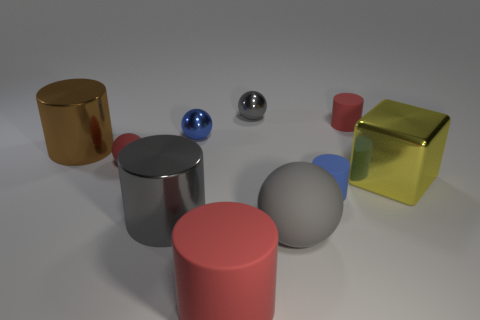How many cylinders are large gray objects or blue things?
Your answer should be compact. 2. How many things are both behind the large yellow metallic block and in front of the small blue metallic object?
Your response must be concise. 2. There is a rubber ball right of the tiny blue metal thing; what is its color?
Offer a terse response. Gray. The yellow block that is made of the same material as the brown cylinder is what size?
Give a very brief answer. Large. What number of brown metallic objects are to the left of the tiny cylinder in front of the large yellow metallic block?
Give a very brief answer. 1. There is a large ball; how many red things are behind it?
Your answer should be very brief. 2. There is a tiny metal sphere behind the red matte cylinder behind the big shiny cylinder behind the metallic block; what color is it?
Offer a very short reply. Gray. There is a matte cylinder on the left side of the gray matte object; is its color the same as the tiny cylinder that is behind the big yellow metal object?
Your response must be concise. Yes. What shape is the gray metal thing that is on the right side of the red thing in front of the yellow metal thing?
Your response must be concise. Sphere. Are there any blue objects that have the same size as the brown metallic cylinder?
Offer a terse response. No. 